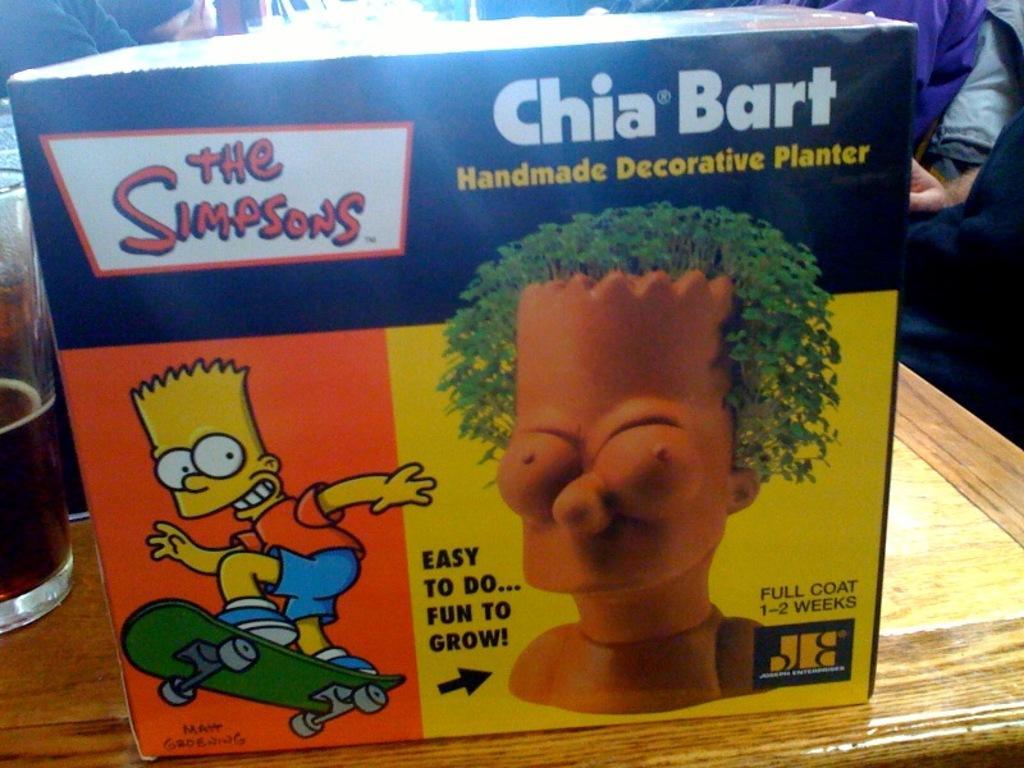Could you give a brief overview of what you see in this image? There is a box on a wooden surface. On the box something is written. Also there are animated characters. On the side of the box there is a glass with a drink. In the background it is not clear. 